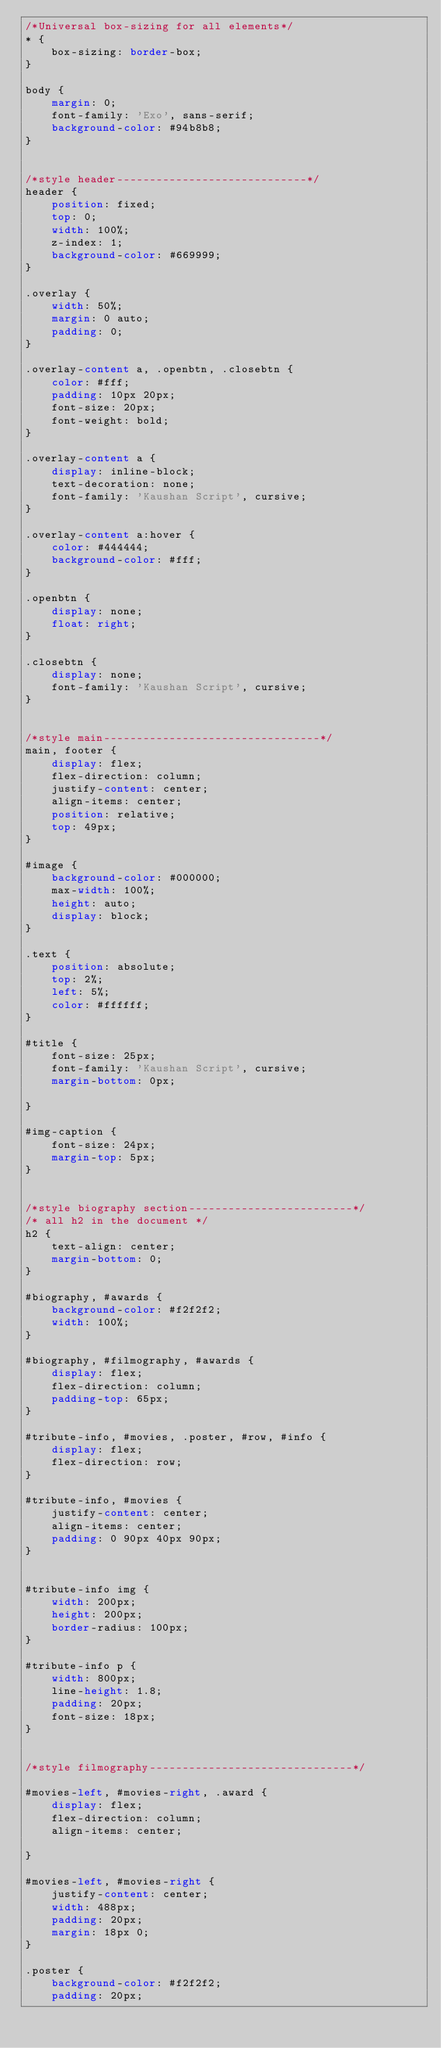Convert code to text. <code><loc_0><loc_0><loc_500><loc_500><_CSS_>/*Universal box-sizing for all elements*/
* {
    box-sizing: border-box;
}

body {
    margin: 0;
    font-family: 'Exo', sans-serif;
    background-color: #94b8b8;
}


/*style header-----------------------------*/
header {
    position: fixed;
    top: 0;
    width: 100%;
    z-index: 1;
    background-color: #669999;
}

.overlay {
    width: 50%;
    margin: 0 auto;
    padding: 0;
}

.overlay-content a, .openbtn, .closebtn {
    color: #fff;
    padding: 10px 20px;
    font-size: 20px;
    font-weight: bold;
}

.overlay-content a {
    display: inline-block;
    text-decoration: none;
    font-family: 'Kaushan Script', cursive;
}

.overlay-content a:hover {
    color: #444444;
    background-color: #fff;
}

.openbtn {
    display: none;
    float: right;
}

.closebtn {
    display: none;
    font-family: 'Kaushan Script', cursive;
}


/*style main---------------------------------*/
main, footer {
    display: flex;
    flex-direction: column;
    justify-content: center;
    align-items: center;
    position: relative;
    top: 49px;
}

#image {
    background-color: #000000;
    max-width: 100%;
    height: auto;
    display: block;
}

.text {
    position: absolute;
    top: 2%;
    left: 5%;
    color: #ffffff;
}

#title {
    font-size: 25px;
    font-family: 'Kaushan Script', cursive;
    margin-bottom: 0px;

}

#img-caption {
    font-size: 24px;
    margin-top: 5px;
}


/*style biography section-------------------------*/
/* all h2 in the document */
h2 {
    text-align: center;
    margin-bottom: 0;
}

#biography, #awards {
    background-color: #f2f2f2;
    width: 100%;
}

#biography, #filmography, #awards {
    display: flex;
    flex-direction: column;
    padding-top: 65px;
}

#tribute-info, #movies, .poster, #row, #info {
    display: flex;
    flex-direction: row;
}

#tribute-info, #movies {
    justify-content: center;
    align-items: center;
    padding: 0 90px 40px 90px;
}


#tribute-info img {
    width: 200px;
    height: 200px;
    border-radius: 100px;
}

#tribute-info p {
    width: 800px;
    line-height: 1.8;
    padding: 20px;
    font-size: 18px;
}


/*style filmography-------------------------------*/

#movies-left, #movies-right, .award {
    display: flex;
    flex-direction: column;
    align-items: center;

}

#movies-left, #movies-right {
    justify-content: center;
    width: 488px;
    padding: 20px;
    margin: 18px 0;
}

.poster {
    background-color: #f2f2f2;
    padding: 20px;</code> 